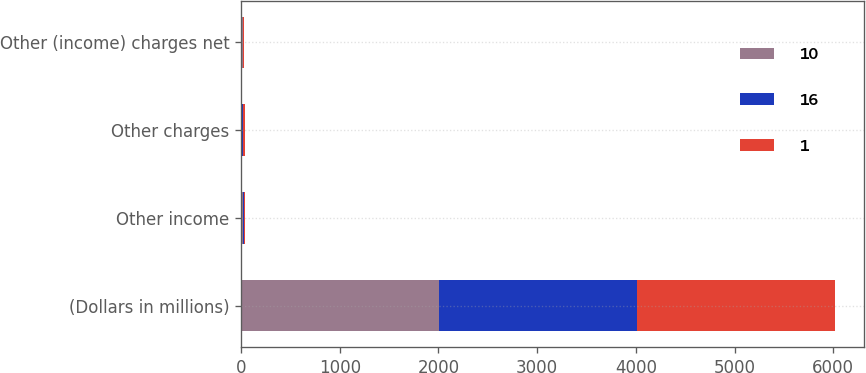Convert chart to OTSL. <chart><loc_0><loc_0><loc_500><loc_500><stacked_bar_chart><ecel><fcel>(Dollars in millions)<fcel>Other income<fcel>Other charges<fcel>Other (income) charges net<nl><fcel>10<fcel>2006<fcel>24<fcel>8<fcel>16<nl><fcel>16<fcel>2005<fcel>11<fcel>12<fcel>1<nl><fcel>1<fcel>2004<fcel>10<fcel>20<fcel>10<nl></chart> 